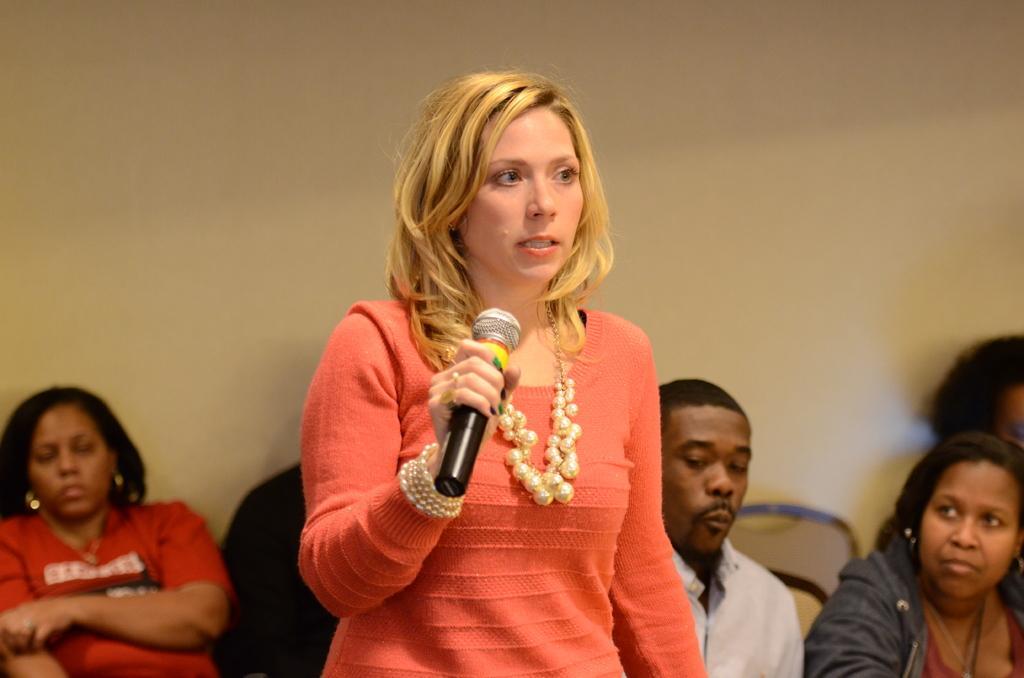Describe this image in one or two sentences. A woman with golden hair is speaking something. She is holding a microphone, She wore a necklaces and hand bracelet. People around her are listening to her. 